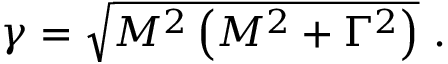Convert formula to latex. <formula><loc_0><loc_0><loc_500><loc_500>\gamma = { \sqrt { M ^ { 2 } \left ( M ^ { 2 } + \Gamma ^ { 2 } \right ) } } .</formula> 